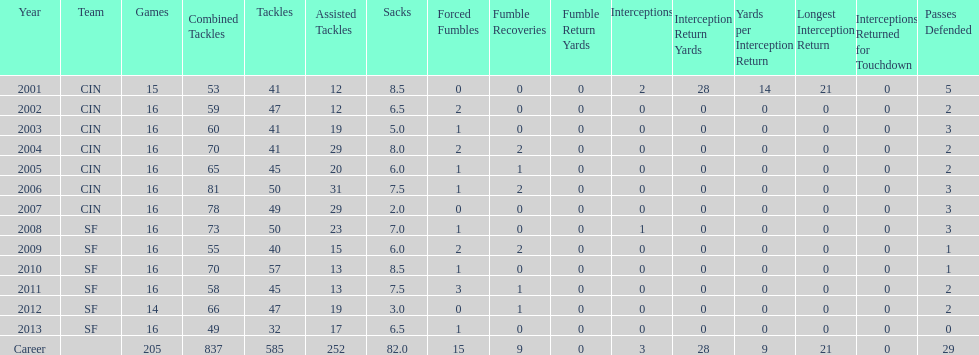How many tackles were combined in the year 2010? 70. 